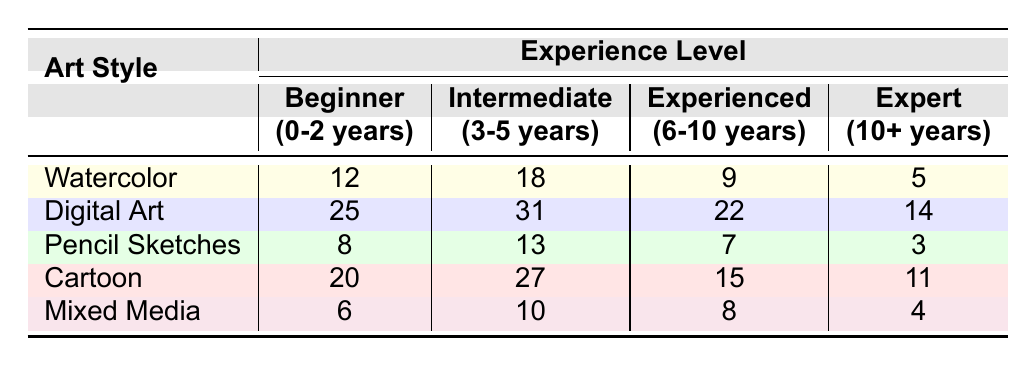What is the highest number of submissions for any art style at the beginner level? Looking at the table, the highest value in the "Beginner" column is 25, which corresponds to "Digital Art."
Answer: 25 How many more submissions are there for "Cartoon" at the beginner level compared to "Mixed Media"? For "Cartoon," there are 20 submissions, and for "Mixed Media," there are 6 submissions. The difference is 20 - 6 = 14.
Answer: 14 What is the total number of submissions across all art styles for the intermediate level? Summing the intermediate submissions: 18 (Watercolor) + 31 (Digital Art) + 13 (Pencil Sketches) + 27 (Cartoon) + 10 (Mixed Media) equals 99.
Answer: 99 Is there a greater number of experienced submissions for "Digital Art" than for "Watercolor"? "Digital Art" has 22 submissions, while "Watercolor" has 9 submissions. Since 22 is greater than 9, the statement is true.
Answer: Yes What is the median number of submissions for cartoon art among all experience levels? The submissions for Cartoon are: 20 (Beginner), 27 (Intermediate), 15 (Experienced), and 11 (Expert). Organizing these values gives: 11, 15, 20, 27. The median is the average of the two middle numbers: (15 + 20) / 2 = 17.5.
Answer: 17.5 Which art style has the least experienced submissions and what is that value? The least experienced submissions are found in "Pencil Sketches" with 7 submissions at the experienced level.
Answer: 7 If we combine the expert submissions from all styles, what will that total be? Adding the expert submissions: 5 (Watercolor) + 14 (Digital Art) + 3 (Pencil Sketches) + 11 (Cartoon) + 4 (Mixed Media) results in 37.
Answer: 37 How many submissions are there for mixed media if we only consider beginner and expert levels? The submissions for "Mixed Media" are 6 at the beginner level and 4 at the expert level. The total is 6 + 4 = 10.
Answer: 10 What is the difference in submissions between the most and least submitted art style at the experienced level? At the experienced level, "Digital Art" has 22 submissions and "Pencil Sketches" has 7 submissions. The difference is 22 - 7 = 15.
Answer: 15 How many submissions are there total in the Digital Art category across all experience levels? Adding submissions: 25 (Beginner) + 31 (Intermediate) + 22 (Experienced) + 14 (Expert) equals 92.
Answer: 92 